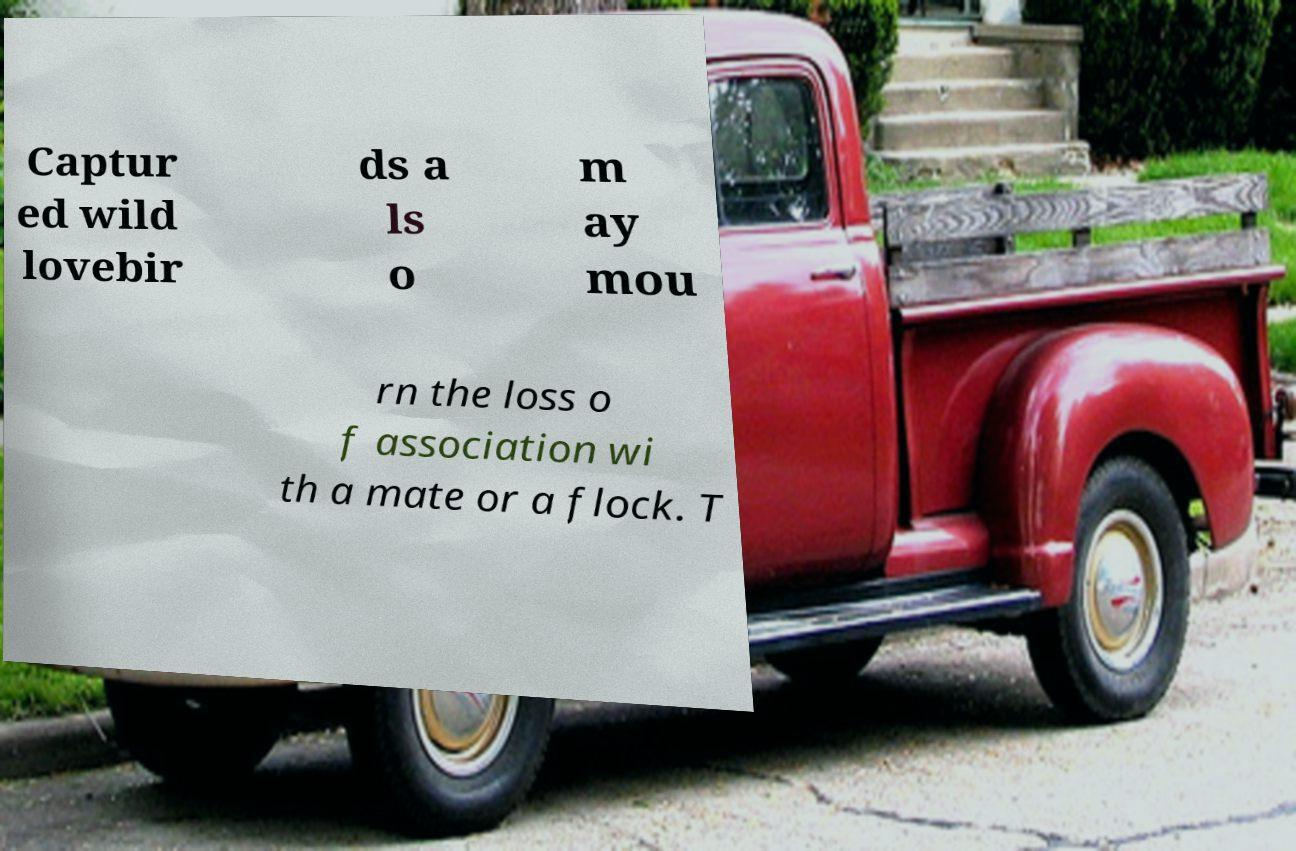Please identify and transcribe the text found in this image. Captur ed wild lovebir ds a ls o m ay mou rn the loss o f association wi th a mate or a flock. T 